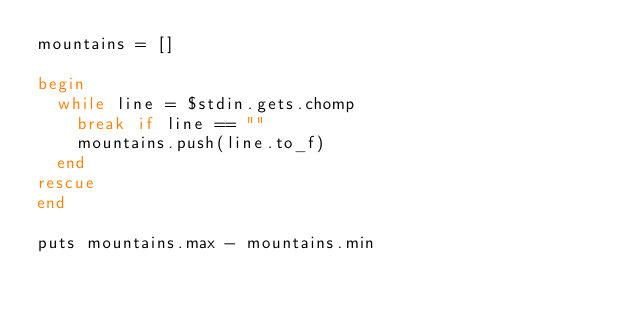Convert code to text. <code><loc_0><loc_0><loc_500><loc_500><_Ruby_>mountains = []

begin
  while line = $stdin.gets.chomp
    break if line == ""
    mountains.push(line.to_f)
  end
rescue
end

puts mountains.max - mountains.min</code> 